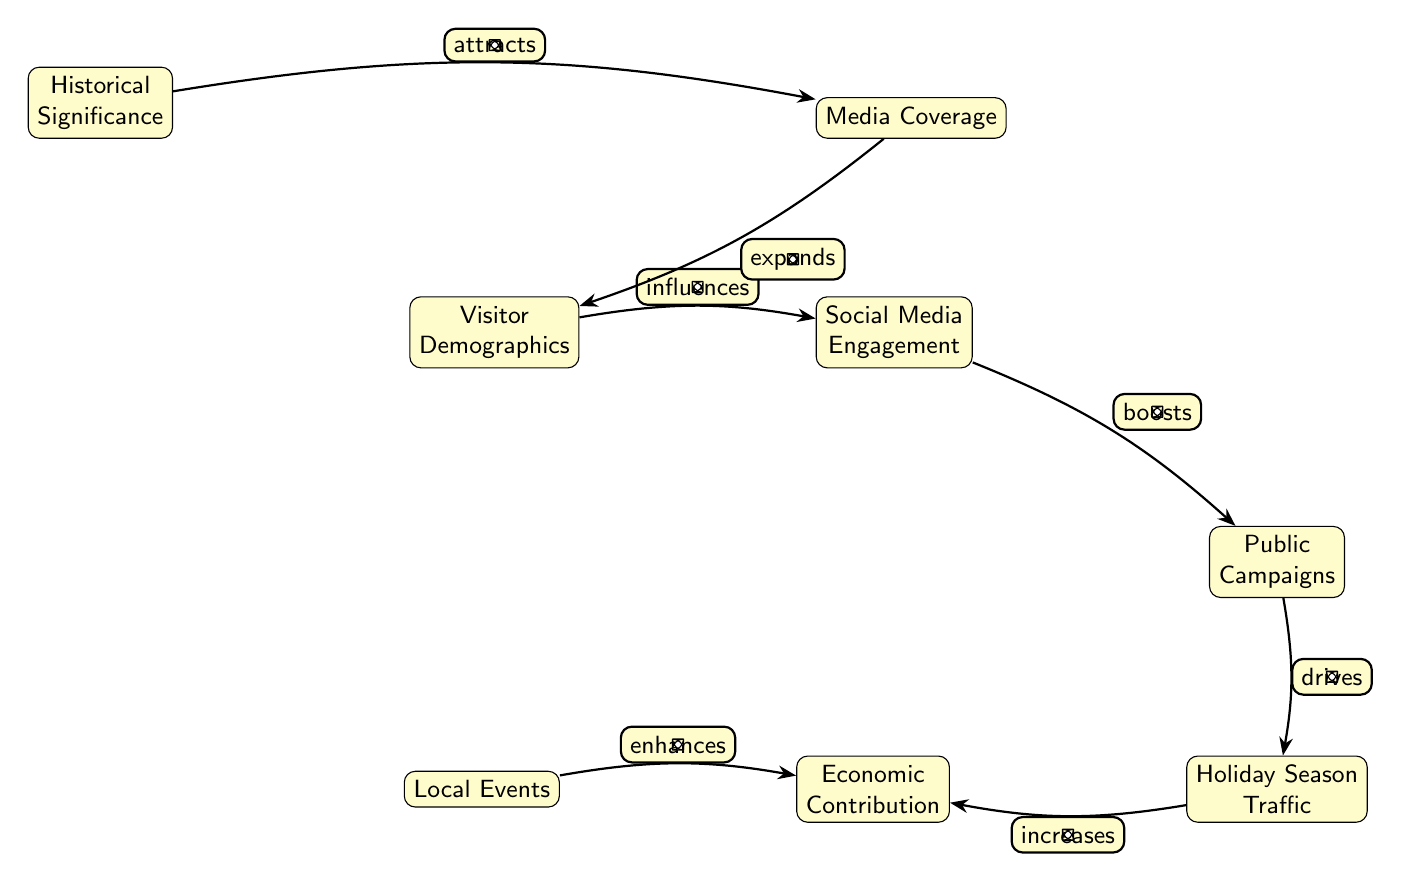What are the main nodes represented in the diagram? The diagram shows seven nodes including Visitor Demographics, Social Media Engagement, Public Campaigns, Holiday Season Traffic, Economic Contribution, Local Events, and Historical Significance.
Answer: Visitor Demographics, Social Media Engagement, Public Campaigns, Holiday Season Traffic, Economic Contribution, Local Events, Historical Significance How many edges are present in the diagram? The diagram contains seven edges connecting different nodes, each representing a relationship between factors influencing public interest.
Answer: Seven Which factor influences public campaigns according to the diagram? The diagram indicates that Social Media Engagement boosts Public Campaigns, showcasing the relationship between online interaction and outreach efforts.
Answer: Social Media Engagement What drives holiday season traffic in the diagram? The diagram shows that Public Campaigns drive Holiday Season Traffic, suggesting that efforts to raise awareness lead to increased visitor numbers.
Answer: Public Campaigns Which node enhances economic contribution alongside local events? According to the diagram, Holiday Season Traffic also increases Economic Contribution, in addition to Local Events.
Answer: Holiday Season Traffic What attracts media coverage in the diagram? The diagram specifies that Historical Significance attracts Media Coverage, indicating its crucial role in drawing public and media interest.
Answer: Historical Significance How does media coverage affect visitor demographics? The diagram illustrates that Media Coverage expands Visitor Demographics, implying that increased exposure leads to a broader audience.
Answer: Expands Which is the last step in the flow of the diagram? The last step in the flow shows that Economic Contribution results from both Holiday Season Traffic and Local Events, demonstrating the outcome of influenced factors.
Answer: Economic Contribution 